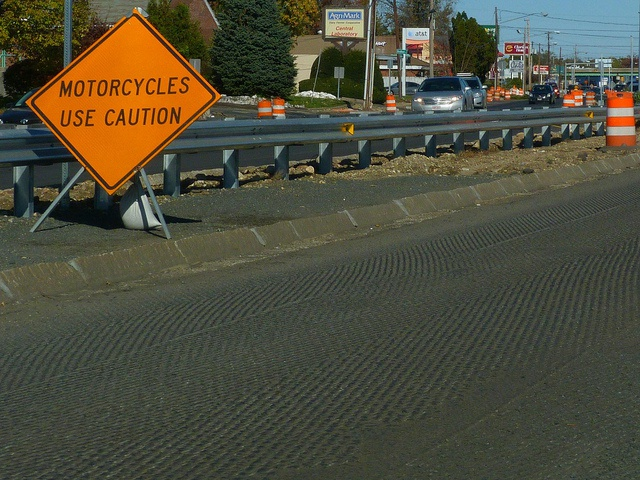Describe the objects in this image and their specific colors. I can see car in black, gray, blue, and darkgray tones, car in black, teal, gray, and navy tones, car in black, purple, and blue tones, car in black, gray, and blue tones, and car in black, darkgreen, gray, and purple tones in this image. 